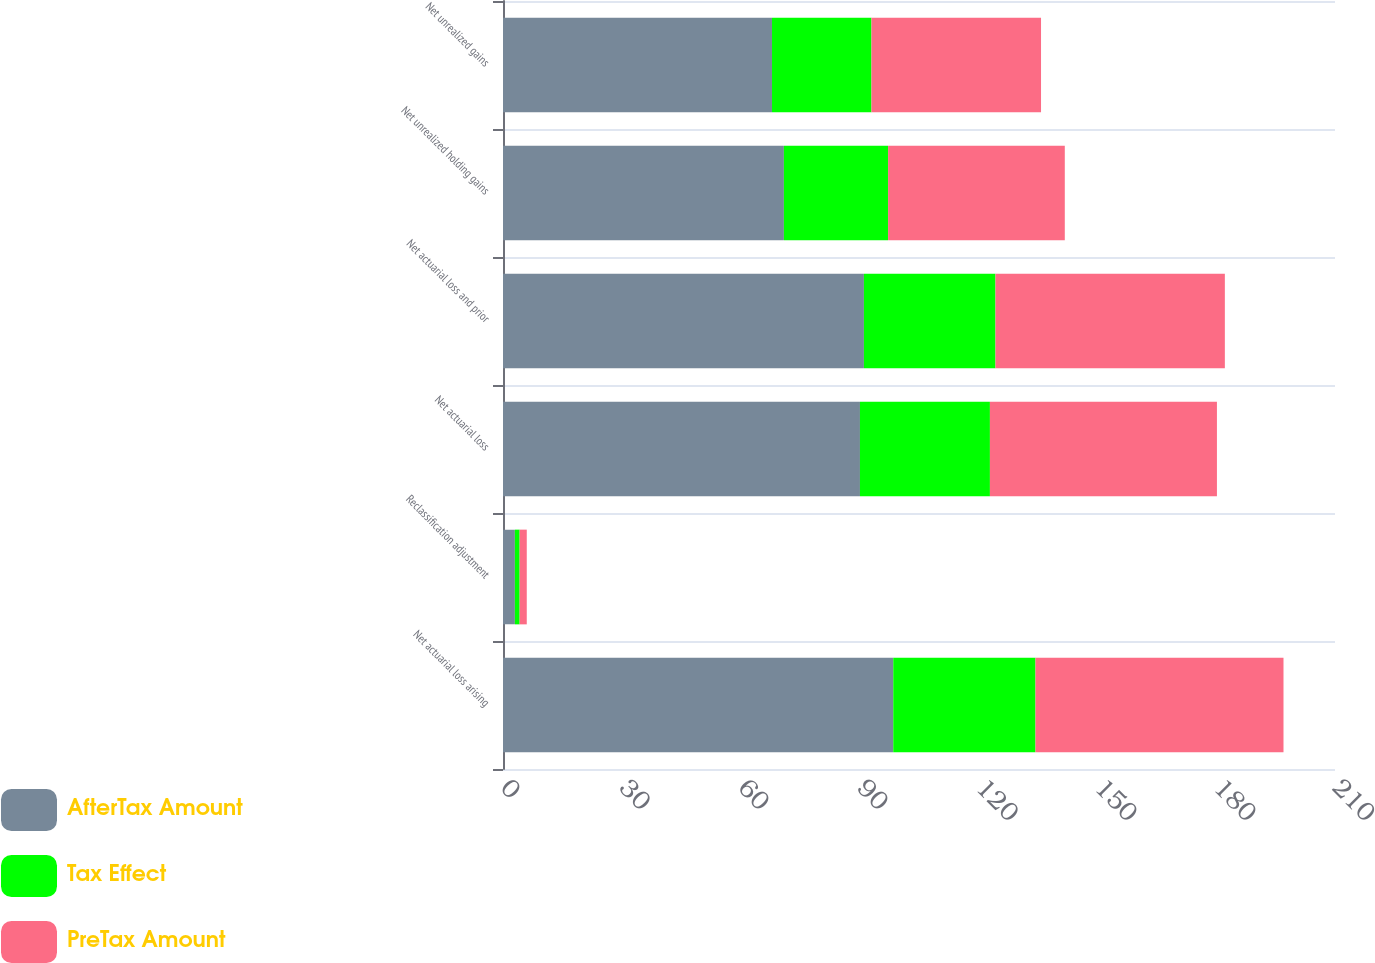Convert chart. <chart><loc_0><loc_0><loc_500><loc_500><stacked_bar_chart><ecel><fcel>Net actuarial loss arising<fcel>Reclassification adjustment<fcel>Net actuarial loss<fcel>Net actuarial loss and prior<fcel>Net unrealized holding gains<fcel>Net unrealized gains<nl><fcel>AfterTax Amount<fcel>98.5<fcel>3<fcel>90.1<fcel>91.1<fcel>70.9<fcel>67.9<nl><fcel>Tax Effect<fcel>35.9<fcel>1.2<fcel>32.8<fcel>33.2<fcel>26.3<fcel>25.1<nl><fcel>PreTax Amount<fcel>62.6<fcel>1.8<fcel>57.3<fcel>57.9<fcel>44.6<fcel>42.8<nl></chart> 